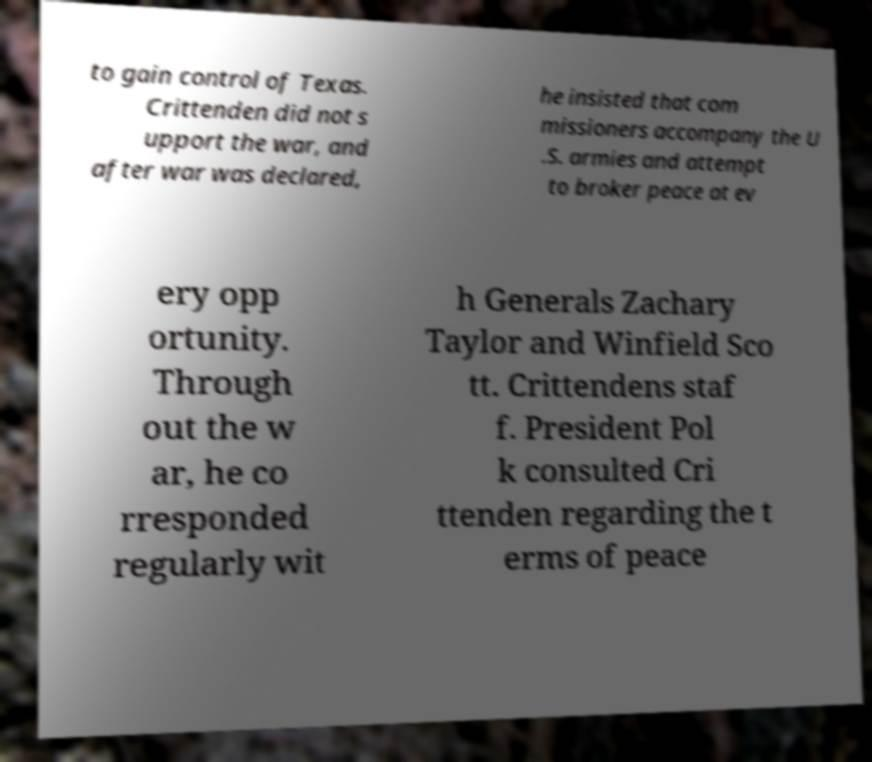What messages or text are displayed in this image? I need them in a readable, typed format. to gain control of Texas. Crittenden did not s upport the war, and after war was declared, he insisted that com missioners accompany the U .S. armies and attempt to broker peace at ev ery opp ortunity. Through out the w ar, he co rresponded regularly wit h Generals Zachary Taylor and Winfield Sco tt. Crittendens staf f. President Pol k consulted Cri ttenden regarding the t erms of peace 